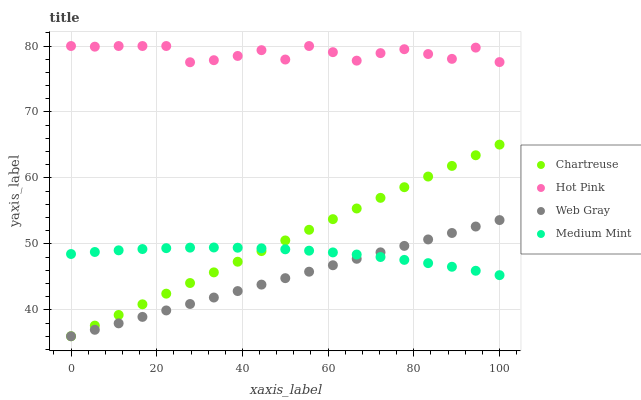Does Web Gray have the minimum area under the curve?
Answer yes or no. Yes. Does Hot Pink have the maximum area under the curve?
Answer yes or no. Yes. Does Chartreuse have the minimum area under the curve?
Answer yes or no. No. Does Chartreuse have the maximum area under the curve?
Answer yes or no. No. Is Chartreuse the smoothest?
Answer yes or no. Yes. Is Hot Pink the roughest?
Answer yes or no. Yes. Is Hot Pink the smoothest?
Answer yes or no. No. Is Chartreuse the roughest?
Answer yes or no. No. Does Chartreuse have the lowest value?
Answer yes or no. Yes. Does Hot Pink have the lowest value?
Answer yes or no. No. Does Hot Pink have the highest value?
Answer yes or no. Yes. Does Chartreuse have the highest value?
Answer yes or no. No. Is Web Gray less than Hot Pink?
Answer yes or no. Yes. Is Hot Pink greater than Medium Mint?
Answer yes or no. Yes. Does Medium Mint intersect Chartreuse?
Answer yes or no. Yes. Is Medium Mint less than Chartreuse?
Answer yes or no. No. Is Medium Mint greater than Chartreuse?
Answer yes or no. No. Does Web Gray intersect Hot Pink?
Answer yes or no. No. 